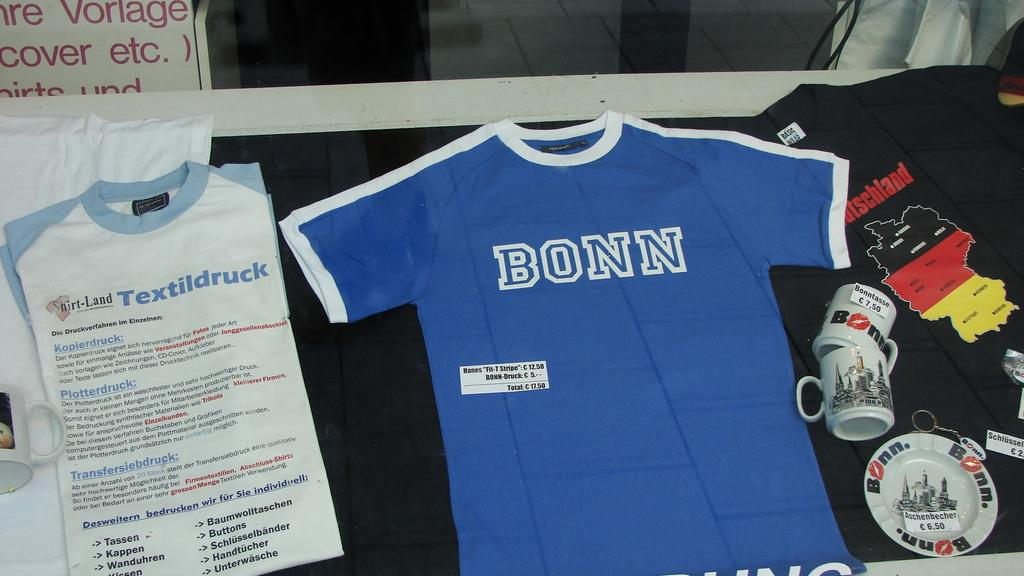<image>
Present a compact description of the photo's key features. A blue jersey is on display, reading "Bonn." 